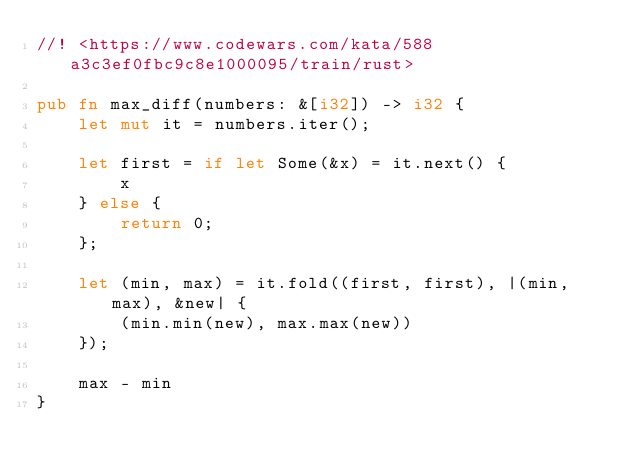Convert code to text. <code><loc_0><loc_0><loc_500><loc_500><_Rust_>//! <https://www.codewars.com/kata/588a3c3ef0fbc9c8e1000095/train/rust>

pub fn max_diff(numbers: &[i32]) -> i32 {
    let mut it = numbers.iter();

    let first = if let Some(&x) = it.next() {
        x
    } else {
        return 0;
    };

    let (min, max) = it.fold((first, first), |(min, max), &new| {
        (min.min(new), max.max(new))
    });

    max - min
}
</code> 